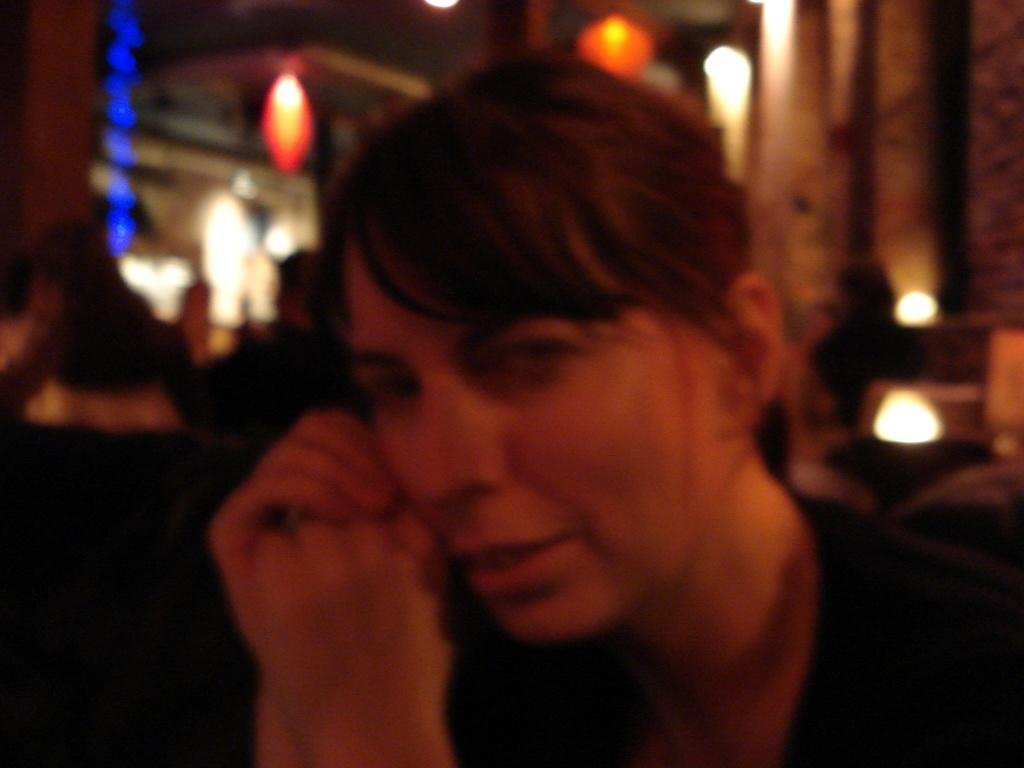Who is the main subject in the foreground of the image? There is a lady in the foreground of the image. What can be seen in the background of the image? There are people in the background of the image. What is illuminating the scene in the image? There are lights visible in the image. What is located on the right side of the image? There is a wall on the right side of the image. What type of powder is being used by the lady in the image? There is no indication of any powder being used by the lady in the image. 